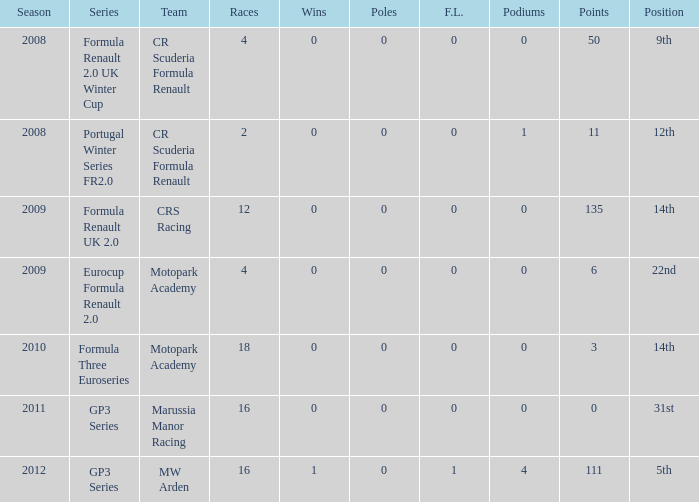What are the most poles listed? 0.0. 